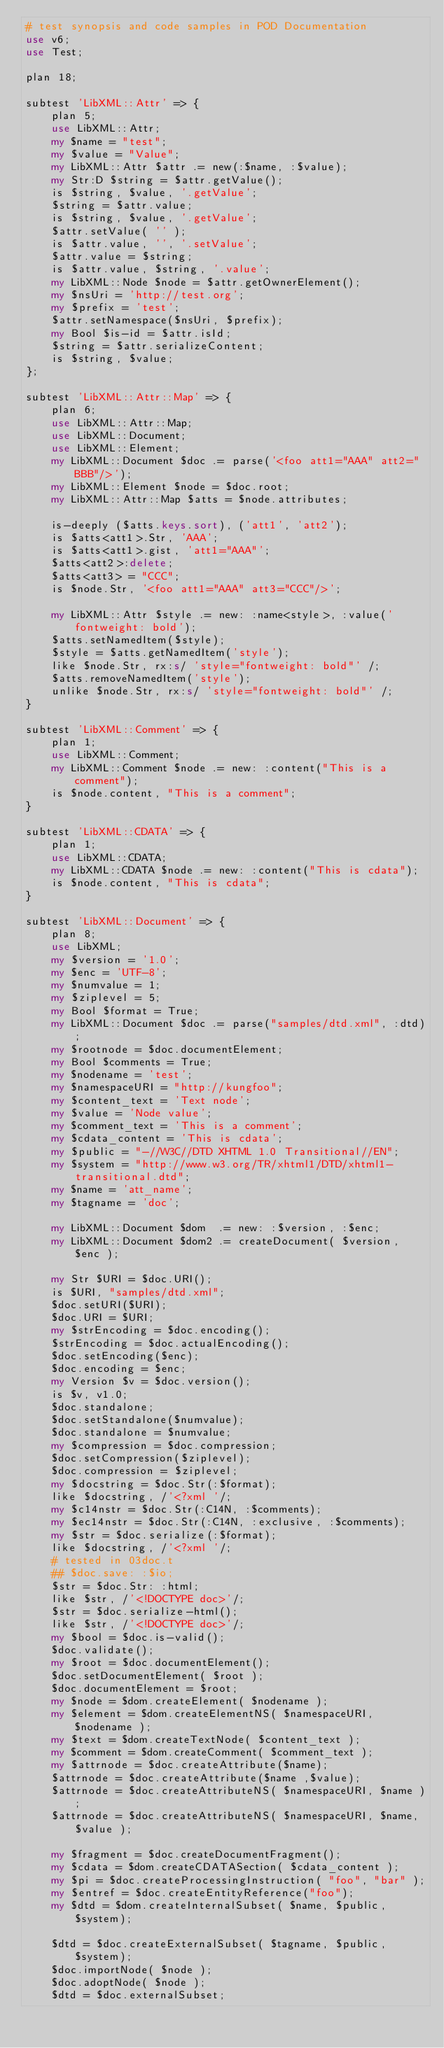Convert code to text. <code><loc_0><loc_0><loc_500><loc_500><_Perl_># test synopsis and code samples in POD Documentation
use v6;
use Test;

plan 18;

subtest 'LibXML::Attr' => {
    plan 5;
    use LibXML::Attr;
    my $name = "test";
    my $value = "Value";
    my LibXML::Attr $attr .= new(:$name, :$value);
    my Str:D $string = $attr.getValue();
    is $string, $value, '.getValue';
    $string = $attr.value;
    is $string, $value, '.getValue';
    $attr.setValue( '' );
    is $attr.value, '', '.setValue';
    $attr.value = $string;
    is $attr.value, $string, '.value';
    my LibXML::Node $node = $attr.getOwnerElement();
    my $nsUri = 'http://test.org';
    my $prefix = 'test';
    $attr.setNamespace($nsUri, $prefix);
    my Bool $is-id = $attr.isId;
    $string = $attr.serializeContent;
    is $string, $value;
};

subtest 'LibXML::Attr::Map' => {
    plan 6;
    use LibXML::Attr::Map;
    use LibXML::Document;
    use LibXML::Element;
    my LibXML::Document $doc .= parse('<foo att1="AAA" att2="BBB"/>');
    my LibXML::Element $node = $doc.root;
    my LibXML::Attr::Map $atts = $node.attributes;

    is-deeply ($atts.keys.sort), ('att1', 'att2');
    is $atts<att1>.Str, 'AAA';
    is $atts<att1>.gist, 'att1="AAA"';
    $atts<att2>:delete;
    $atts<att3> = "CCC";
    is $node.Str, '<foo att1="AAA" att3="CCC"/>';

    my LibXML::Attr $style .= new: :name<style>, :value('fontweight: bold');
    $atts.setNamedItem($style);
    $style = $atts.getNamedItem('style');
    like $node.Str, rx:s/ 'style="fontweight: bold"' /;
    $atts.removeNamedItem('style');
    unlike $node.Str, rx:s/ 'style="fontweight: bold"' /;
}

subtest 'LibXML::Comment' => {
    plan 1;
    use LibXML::Comment;
    my LibXML::Comment $node .= new: :content("This is a comment");
    is $node.content, "This is a comment";
}

subtest 'LibXML::CDATA' => {
    plan 1;
    use LibXML::CDATA;
    my LibXML::CDATA $node .= new: :content("This is cdata");
    is $node.content, "This is cdata";
}

subtest 'LibXML::Document' => {
    plan 8;
    use LibXML;
    my $version = '1.0';
    my $enc = 'UTF-8';
    my $numvalue = 1;
    my $ziplevel = 5;
    my Bool $format = True;
    my LibXML::Document $doc .= parse("samples/dtd.xml", :dtd);
    my $rootnode = $doc.documentElement;
    my Bool $comments = True;
    my $nodename = 'test';
    my $namespaceURI = "http://kungfoo";
    my $content_text = 'Text node';
    my $value = 'Node value';
    my $comment_text = 'This is a comment';
    my $cdata_content = 'This is cdata';
    my $public = "-//W3C//DTD XHTML 1.0 Transitional//EN";
    my $system = "http://www.w3.org/TR/xhtml1/DTD/xhtml1-transitional.dtd";
    my $name = 'att_name';
    my $tagname = 'doc';

    my LibXML::Document $dom  .= new: :$version, :$enc;
    my LibXML::Document $dom2 .= createDocument( $version, $enc );

    my Str $URI = $doc.URI();
    is $URI, "samples/dtd.xml";
    $doc.setURI($URI);
    $doc.URI = $URI;
    my $strEncoding = $doc.encoding();
    $strEncoding = $doc.actualEncoding();
    $doc.setEncoding($enc);
    $doc.encoding = $enc;
    my Version $v = $doc.version();
    is $v, v1.0;
    $doc.standalone;
    $doc.setStandalone($numvalue);
    $doc.standalone = $numvalue;
    my $compression = $doc.compression;
    $doc.setCompression($ziplevel);
    $doc.compression = $ziplevel;
    my $docstring = $doc.Str(:$format);
    like $docstring, /'<?xml '/;
    my $c14nstr = $doc.Str(:C14N, :$comments);
    my $ec14nstr = $doc.Str(:C14N, :exclusive, :$comments);
    my $str = $doc.serialize(:$format);
    like $docstring, /'<?xml '/;
    # tested in 03doc.t
    ## $doc.save: :$io;
    $str = $doc.Str: :html;
    like $str, /'<!DOCTYPE doc>'/;
    $str = $doc.serialize-html();
    like $str, /'<!DOCTYPE doc>'/;
    my $bool = $doc.is-valid();
    $doc.validate();
    my $root = $doc.documentElement();
    $doc.setDocumentElement( $root );
    $doc.documentElement = $root;
    my $node = $dom.createElement( $nodename );
    my $element = $dom.createElementNS( $namespaceURI, $nodename );
    my $text = $dom.createTextNode( $content_text );
    my $comment = $dom.createComment( $comment_text );
    my $attrnode = $doc.createAttribute($name);
    $attrnode = $doc.createAttribute($name ,$value);
    $attrnode = $doc.createAttributeNS( $namespaceURI, $name );
    $attrnode = $doc.createAttributeNS( $namespaceURI, $name, $value );

    my $fragment = $doc.createDocumentFragment();
    my $cdata = $dom.createCDATASection( $cdata_content );
    my $pi = $doc.createProcessingInstruction( "foo", "bar" );
    my $entref = $doc.createEntityReference("foo");
    my $dtd = $dom.createInternalSubset( $name, $public, $system);

    $dtd = $doc.createExternalSubset( $tagname, $public, $system);
    $doc.importNode( $node );
    $doc.adoptNode( $node );
    $dtd = $doc.externalSubset;</code> 